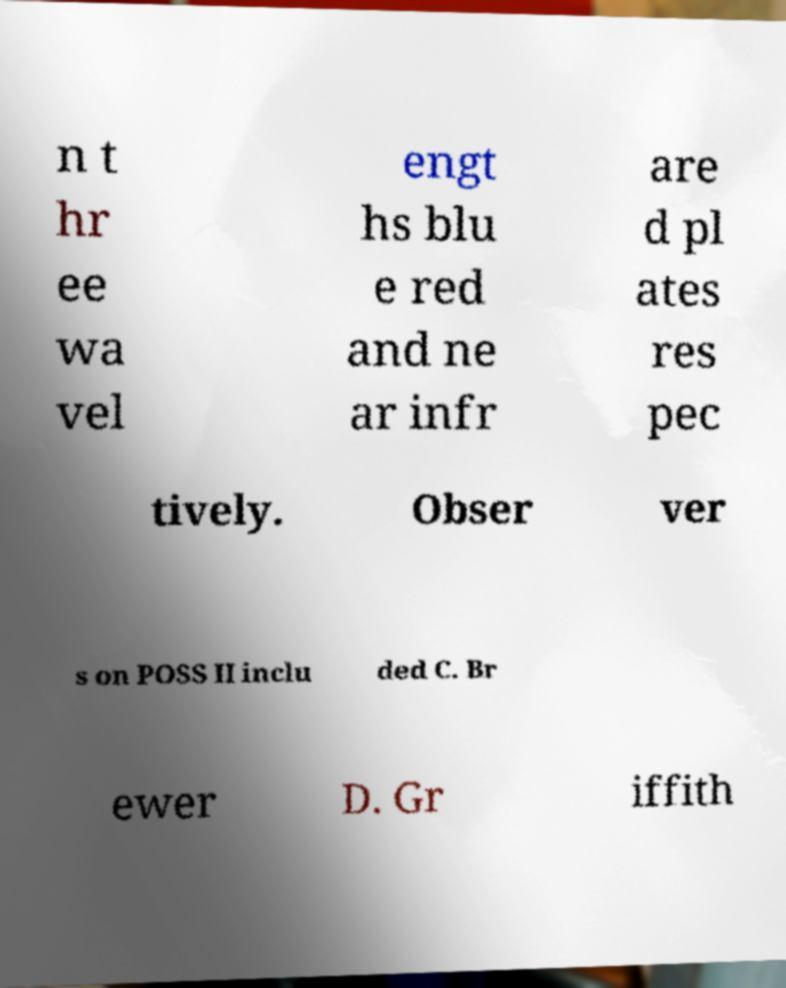I need the written content from this picture converted into text. Can you do that? n t hr ee wa vel engt hs blu e red and ne ar infr are d pl ates res pec tively. Obser ver s on POSS II inclu ded C. Br ewer D. Gr iffith 